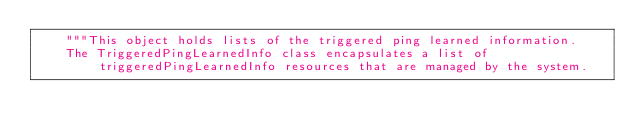<code> <loc_0><loc_0><loc_500><loc_500><_Python_>    """This object holds lists of the triggered ping learned information.
    The TriggeredPingLearnedInfo class encapsulates a list of triggeredPingLearnedInfo resources that are managed by the system.</code> 